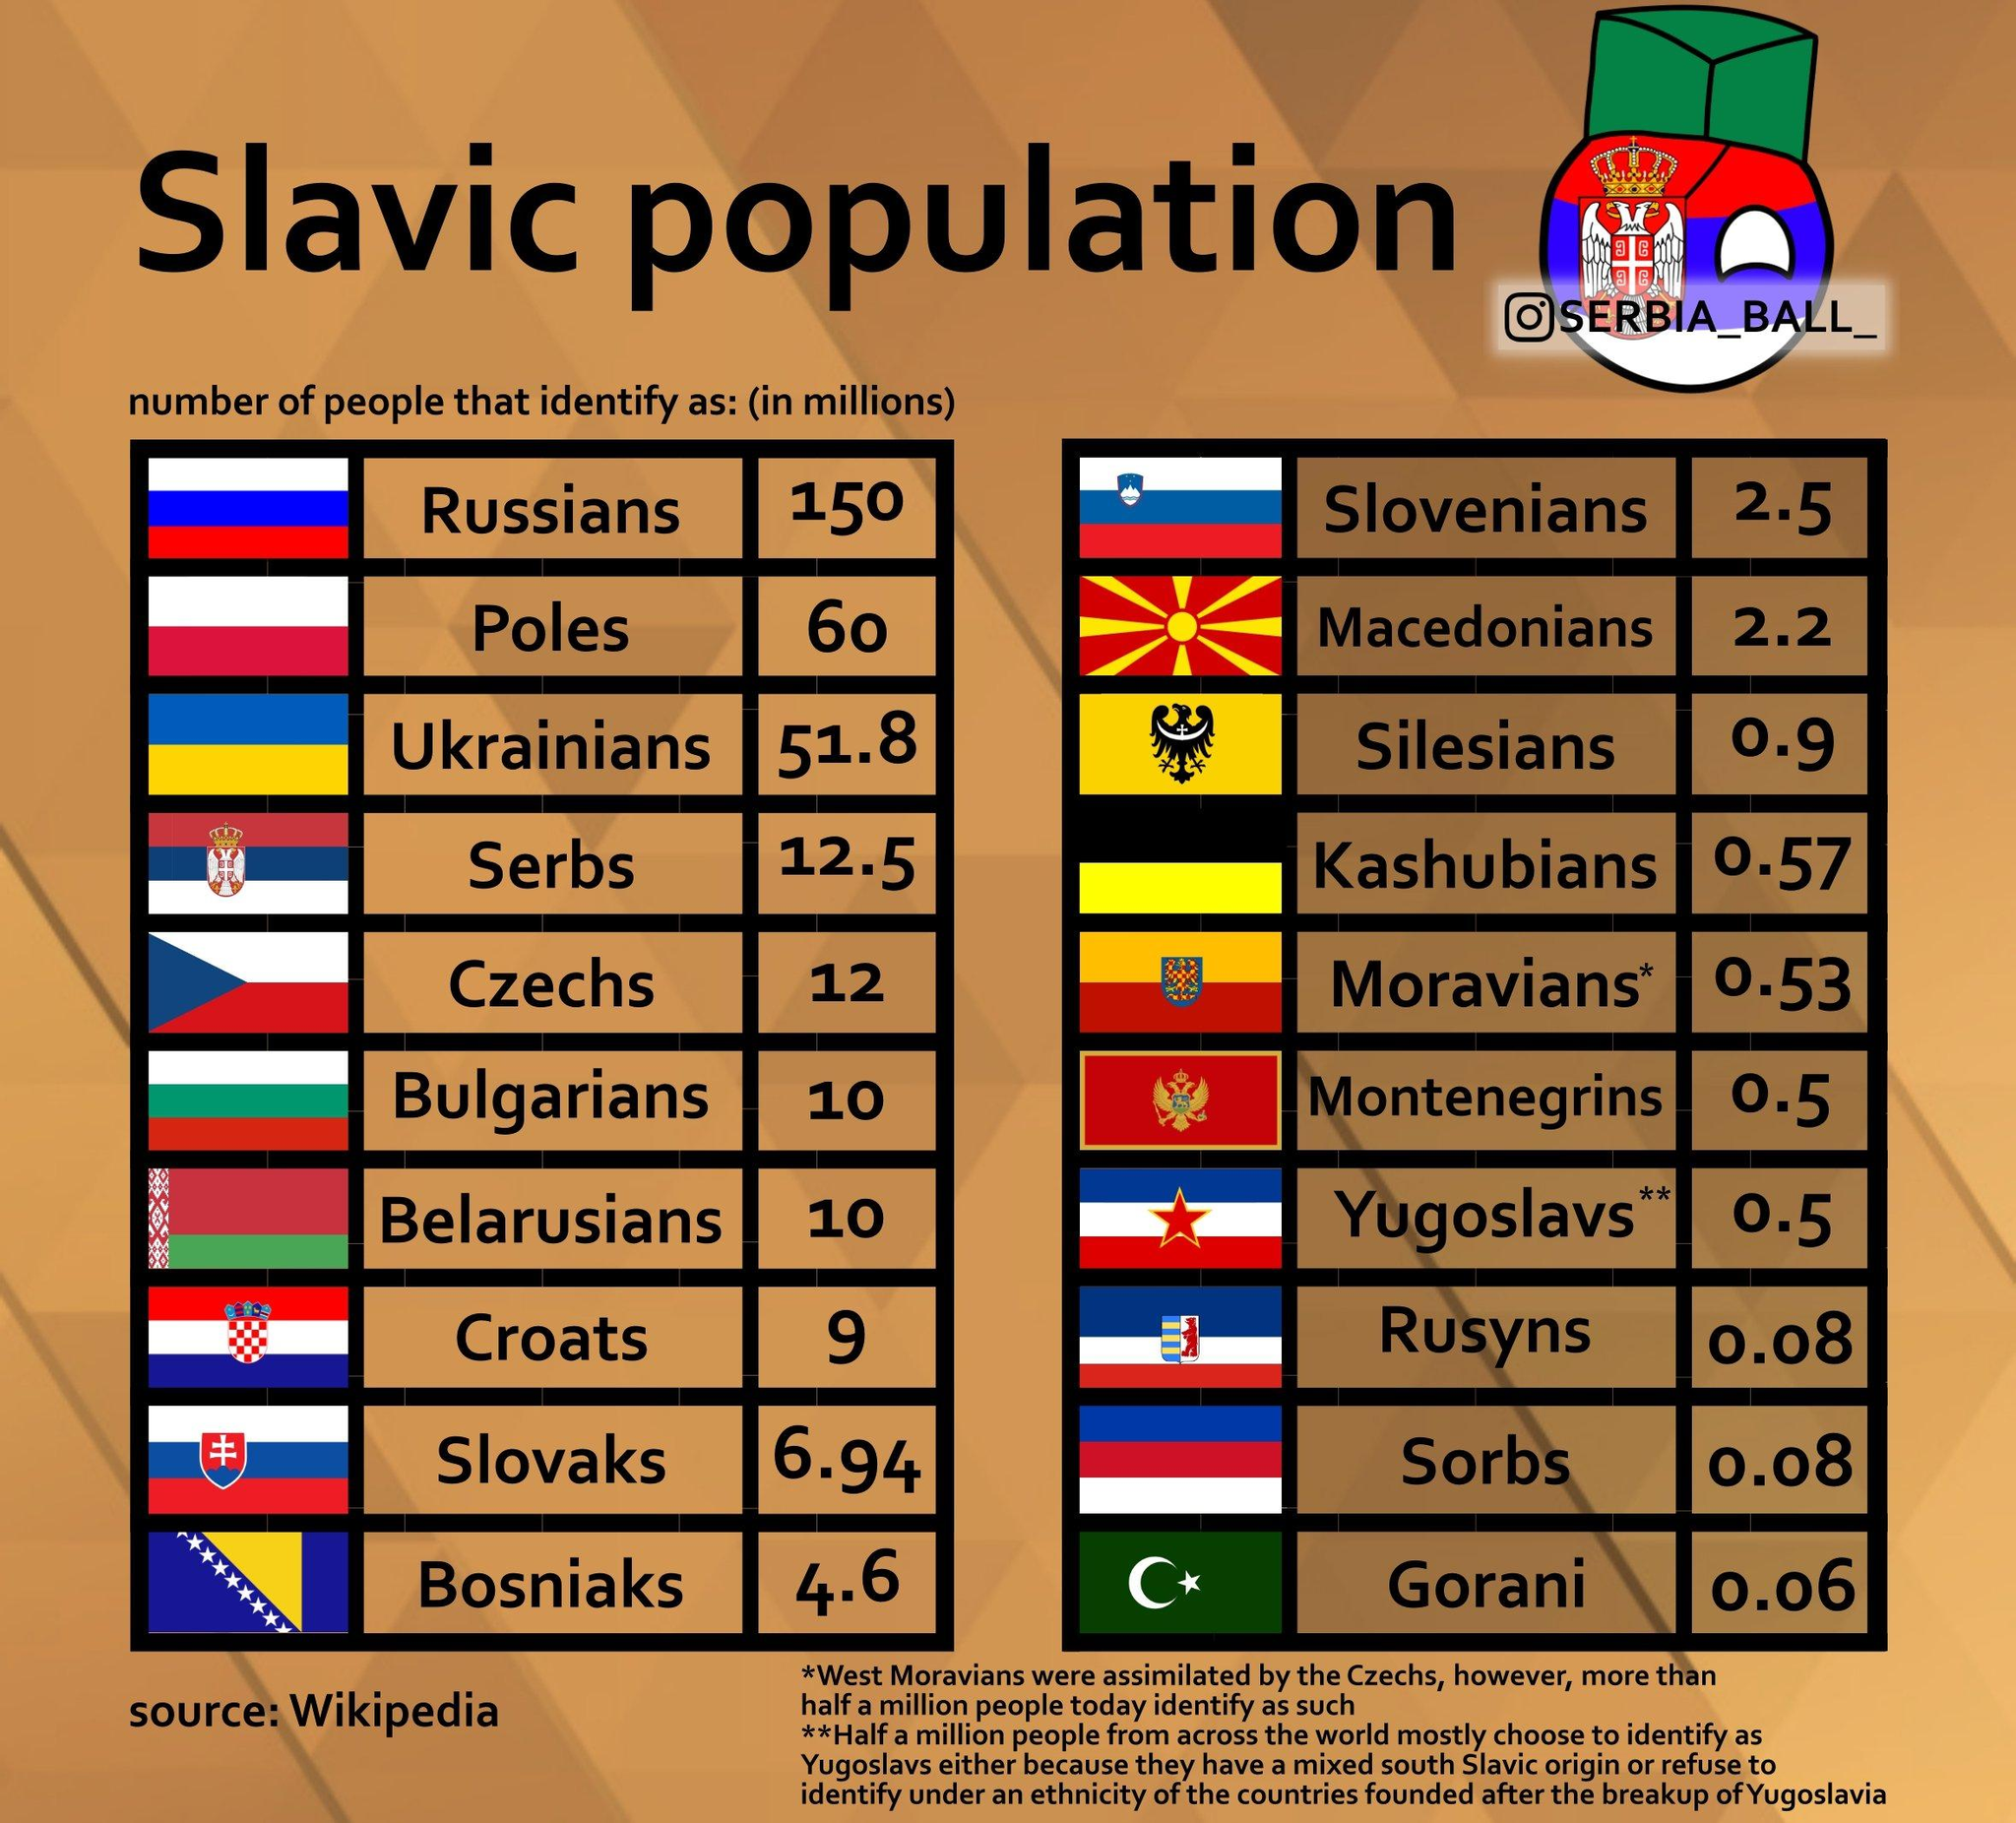Identify some key points in this picture. The Slavic population of Russians and Poles, taken together, is approximately 210 million. The combined Slavic population of Bulgarians and Croats is approximately 19... The Slavic population of the Sorbs and Gorani, taken together, is estimated to be 0.14%. The combined Slavic population of Slovaks and Bosniaks is approximately 11.54... The Slavic population of Silesians and Rusyns, taken together, is 0.98%. 